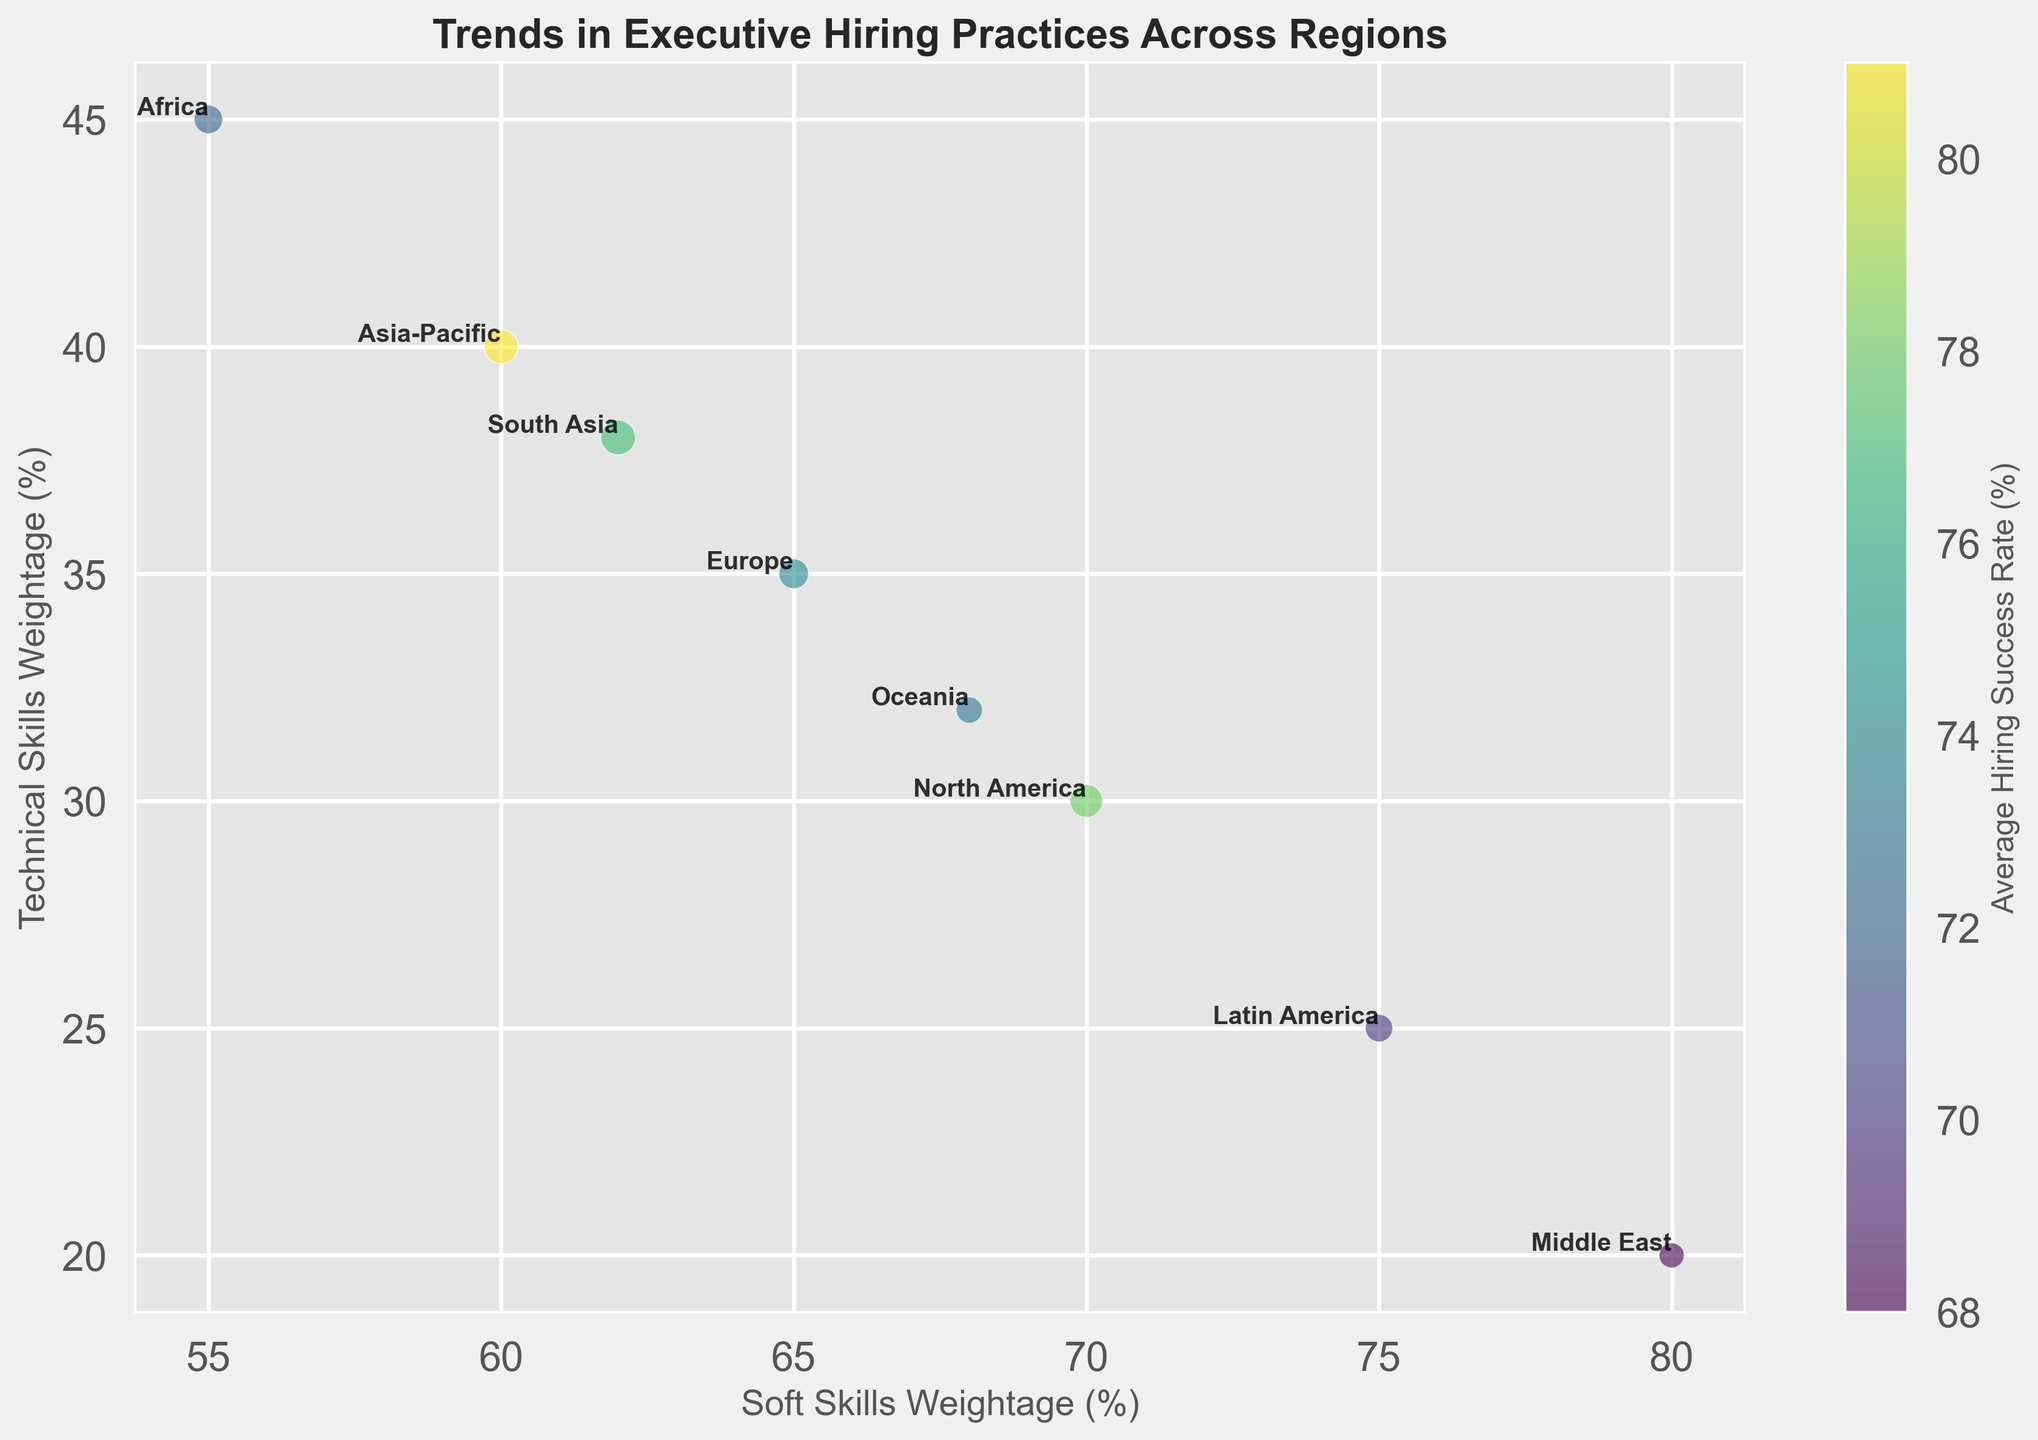What region gives the most emphasis on soft skills? By looking at the Bubble Chart, you can see that the Middle East region has the highest soft skills weightage.
Answer: Middle East Which region has the highest average hiring success rate? The figure shows that Asia-Pacific has the highest average hiring success rate as indicated by the brightest (most yellow) bubble.
Answer: Asia-Pacific Compare the hiring frequencies of North America and Asia-Pacific. Which is higher? North America has a hiring frequency of 85, while Asia-Pacific has a hiring frequency of 90. 90 is greater than 85.
Answer: Asia-Pacific What is the relationship between soft skills weightage and average hiring success rate for Latin America and Africa? Latin America has a soft skills weightage of 75% and an average hiring success rate of 70%. Africa has a soft skills weightage of 55% and an average hiring success rate of 72%. With higher soft skills weightage, Latin America has weaker average hiring success.
Answer: Latin America has higher soft skills weightage but lower success rate than Africa Which two regions have the closest technical skills weightage, and what are those values? Europe has a technical skills weightage of 35% and Oceania has a technical skills weightage of 32%. 35% and 32% are the closest values.
Answer: Europe and Oceania, 35% and 32% Calculate the average hiring success rate of regions with over 70% soft skills weightage. These regions are North America (78%), Latin America (70%), Middle East (68%), and Oceania (73%). Adding these gives 78 + 70 + 68 + 73 = 289. Divide by 4 to get 72.25%.
Answer: 72.25% How does South Asia’s technical skills weightage compare to Europe’s? South Asia has a technical skills weightage of 38% whereas Europe has a weightage of 35%. 38% is greater than 35%.
Answer: South Asia has a higher technical skills weightage Examine the color gradient used in the bubbles. Which regions fall into the lowest average hiring success rate category based on color, and what are their approximate success rates? The darker colored bubbles correspond to lower hiring success rates. Middle East (68%) and Latin America (70%), both appear to have darker shades of green and thus lower success rates.
Answer: Middle East and Latin America, approximately 68% and 70% Identify the region with the smallest bubble size and name the corresponding hiring frequency. The Middle East has the smallest bubble size, indicating the lowest hiring frequency of 50.
Answer: Middle East, 50 